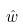<formula> <loc_0><loc_0><loc_500><loc_500>\hat { w }</formula> 